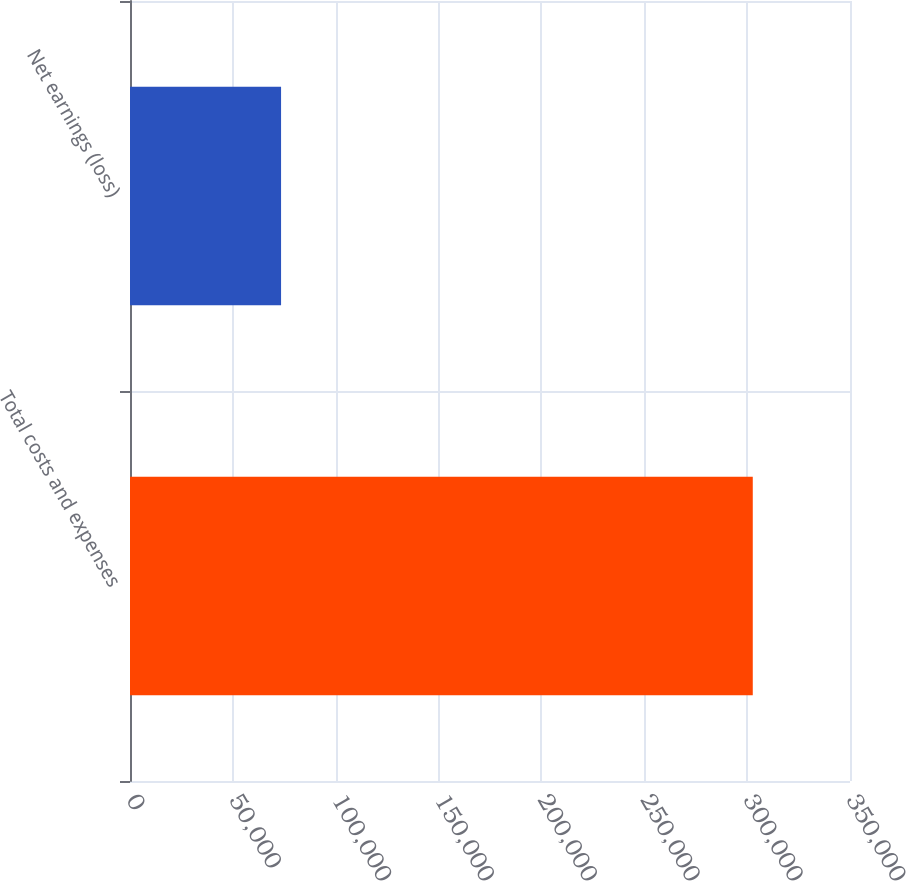<chart> <loc_0><loc_0><loc_500><loc_500><bar_chart><fcel>Total costs and expenses<fcel>Net earnings (loss)<nl><fcel>302738<fcel>73434<nl></chart> 